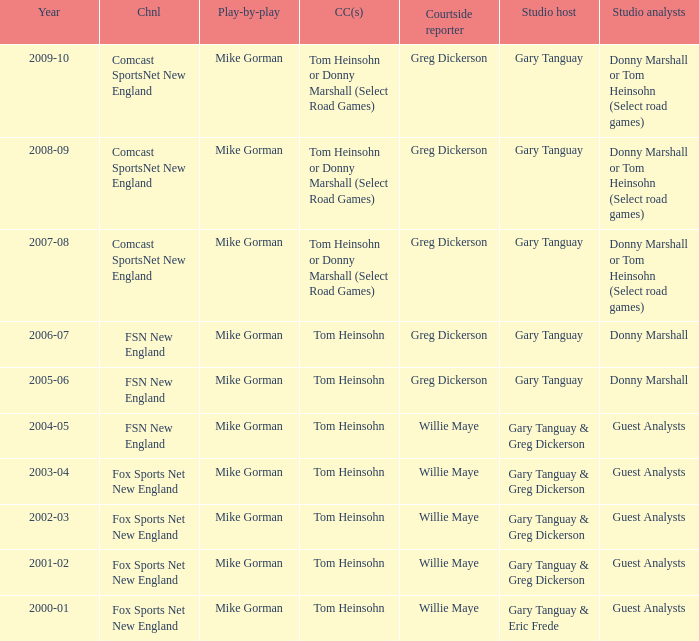Which Color commentator has a Channel of fsn new england, and a Year of 2004-05? Tom Heinsohn. I'm looking to parse the entire table for insights. Could you assist me with that? {'header': ['Year', 'Chnl', 'Play-by-play', 'CC(s)', 'Courtside reporter', 'Studio host', 'Studio analysts'], 'rows': [['2009-10', 'Comcast SportsNet New England', 'Mike Gorman', 'Tom Heinsohn or Donny Marshall (Select Road Games)', 'Greg Dickerson', 'Gary Tanguay', 'Donny Marshall or Tom Heinsohn (Select road games)'], ['2008-09', 'Comcast SportsNet New England', 'Mike Gorman', 'Tom Heinsohn or Donny Marshall (Select Road Games)', 'Greg Dickerson', 'Gary Tanguay', 'Donny Marshall or Tom Heinsohn (Select road games)'], ['2007-08', 'Comcast SportsNet New England', 'Mike Gorman', 'Tom Heinsohn or Donny Marshall (Select Road Games)', 'Greg Dickerson', 'Gary Tanguay', 'Donny Marshall or Tom Heinsohn (Select road games)'], ['2006-07', 'FSN New England', 'Mike Gorman', 'Tom Heinsohn', 'Greg Dickerson', 'Gary Tanguay', 'Donny Marshall'], ['2005-06', 'FSN New England', 'Mike Gorman', 'Tom Heinsohn', 'Greg Dickerson', 'Gary Tanguay', 'Donny Marshall'], ['2004-05', 'FSN New England', 'Mike Gorman', 'Tom Heinsohn', 'Willie Maye', 'Gary Tanguay & Greg Dickerson', 'Guest Analysts'], ['2003-04', 'Fox Sports Net New England', 'Mike Gorman', 'Tom Heinsohn', 'Willie Maye', 'Gary Tanguay & Greg Dickerson', 'Guest Analysts'], ['2002-03', 'Fox Sports Net New England', 'Mike Gorman', 'Tom Heinsohn', 'Willie Maye', 'Gary Tanguay & Greg Dickerson', 'Guest Analysts'], ['2001-02', 'Fox Sports Net New England', 'Mike Gorman', 'Tom Heinsohn', 'Willie Maye', 'Gary Tanguay & Greg Dickerson', 'Guest Analysts'], ['2000-01', 'Fox Sports Net New England', 'Mike Gorman', 'Tom Heinsohn', 'Willie Maye', 'Gary Tanguay & Eric Frede', 'Guest Analysts']]} 